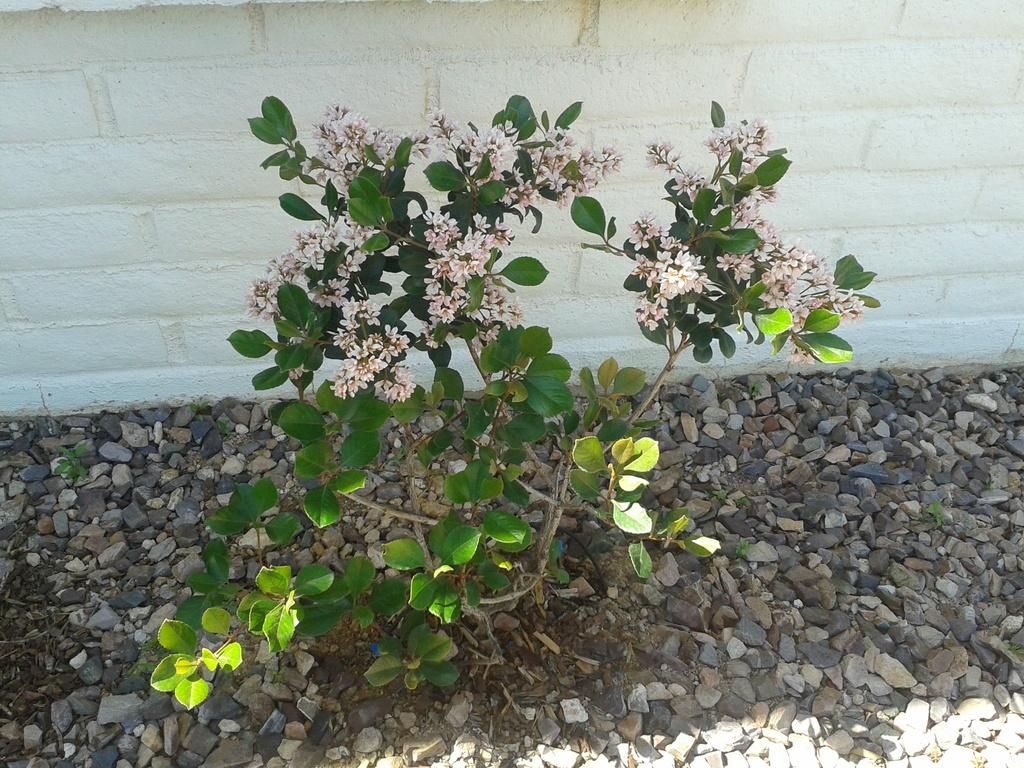What type of plants can be seen on the stones in the image? There are flower plants on the stones in the image. What is visible behind the stones and plants? There is a white wall at the back in the image. Where is the man standing in the image? There is no man present in the image. What type of store can be seen in the image? There is no store visible in the image. 